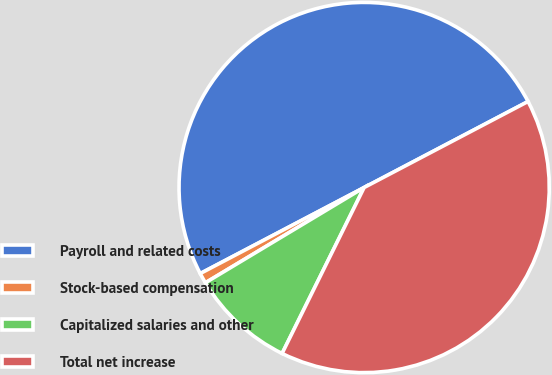Convert chart. <chart><loc_0><loc_0><loc_500><loc_500><pie_chart><fcel>Payroll and related costs<fcel>Stock-based compensation<fcel>Capitalized salaries and other<fcel>Total net increase<nl><fcel>50.0%<fcel>0.91%<fcel>9.09%<fcel>40.0%<nl></chart> 